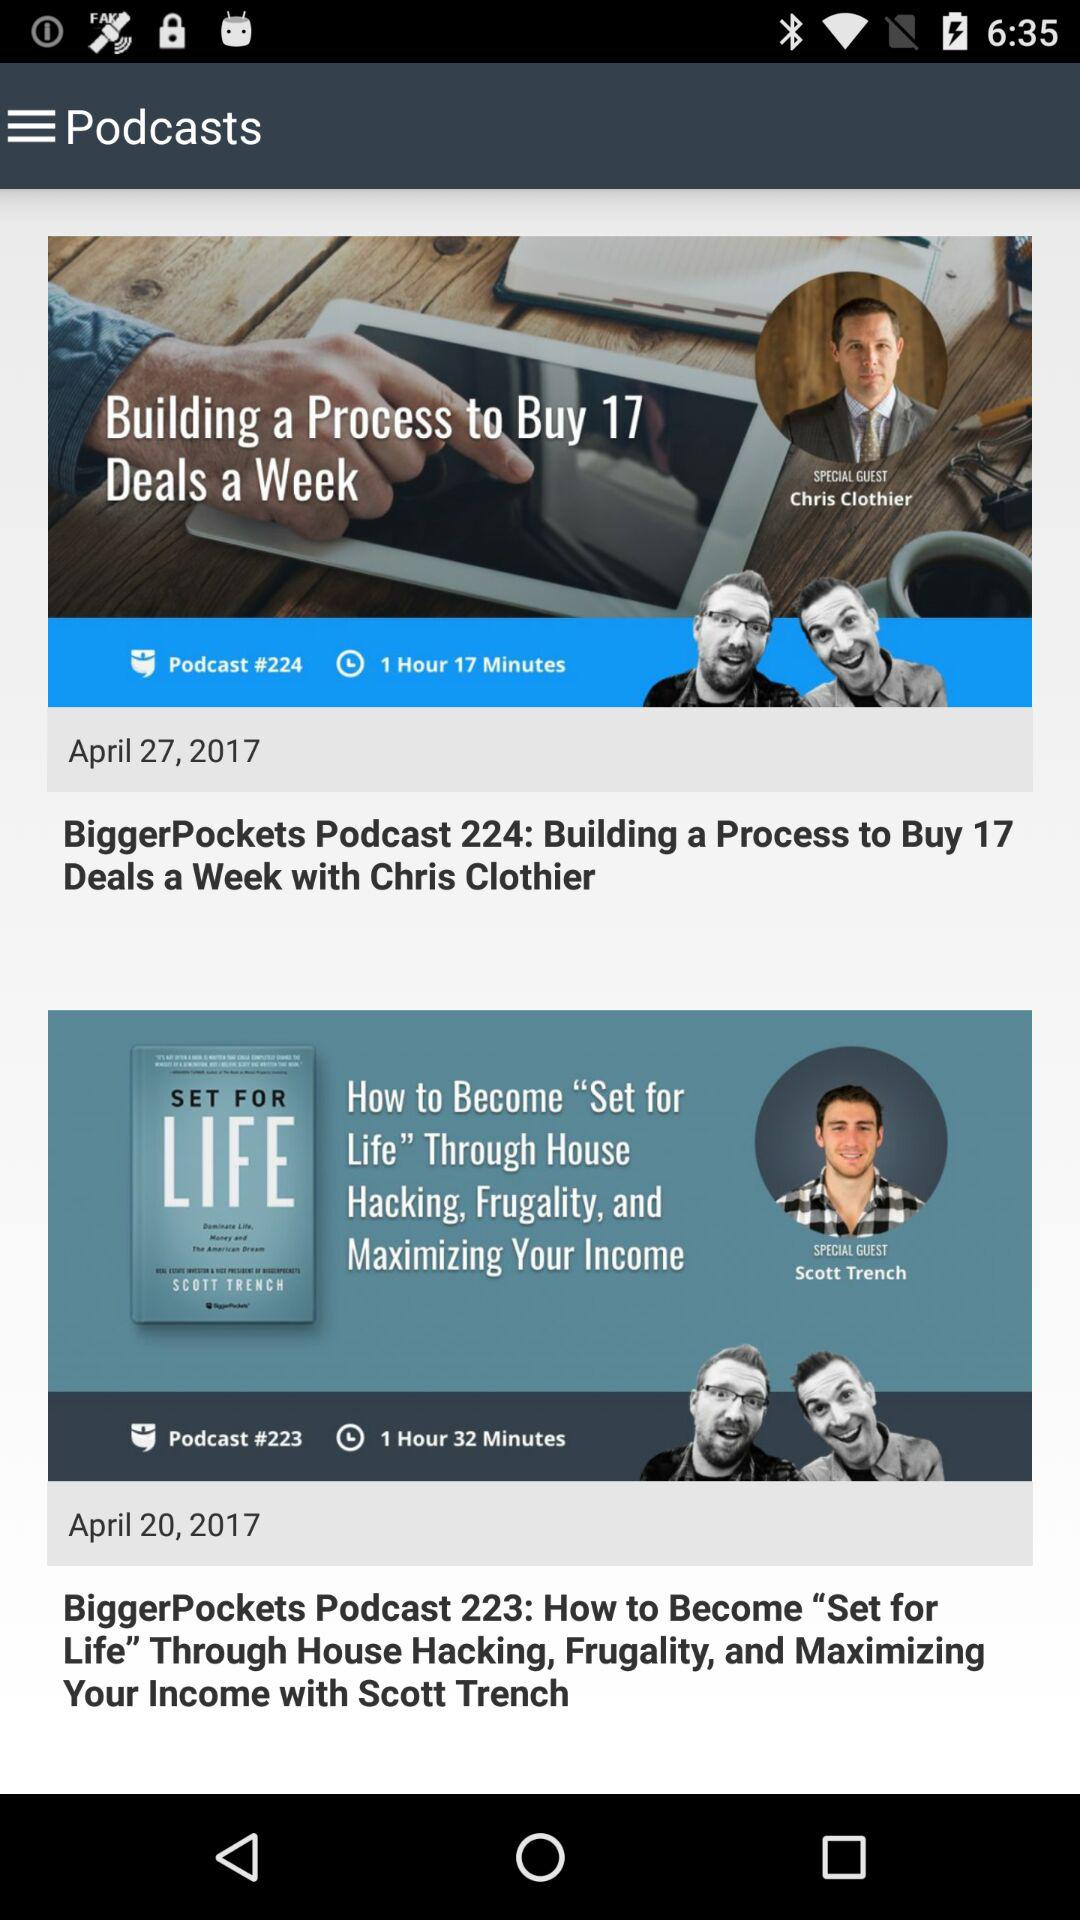On what date was "BiggerPockets Podcast 224" posted? "BiggerPockets Podcast 224" was posted on April 27, 2017. 